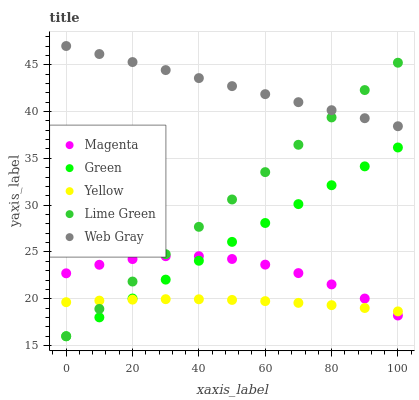Does Yellow have the minimum area under the curve?
Answer yes or no. Yes. Does Web Gray have the maximum area under the curve?
Answer yes or no. Yes. Does Magenta have the minimum area under the curve?
Answer yes or no. No. Does Magenta have the maximum area under the curve?
Answer yes or no. No. Is Green the smoothest?
Answer yes or no. Yes. Is Magenta the roughest?
Answer yes or no. Yes. Is Web Gray the smoothest?
Answer yes or no. No. Is Web Gray the roughest?
Answer yes or no. No. Does Lime Green have the lowest value?
Answer yes or no. Yes. Does Magenta have the lowest value?
Answer yes or no. No. Does Web Gray have the highest value?
Answer yes or no. Yes. Does Magenta have the highest value?
Answer yes or no. No. Is Green less than Web Gray?
Answer yes or no. Yes. Is Web Gray greater than Magenta?
Answer yes or no. Yes. Does Magenta intersect Lime Green?
Answer yes or no. Yes. Is Magenta less than Lime Green?
Answer yes or no. No. Is Magenta greater than Lime Green?
Answer yes or no. No. Does Green intersect Web Gray?
Answer yes or no. No. 